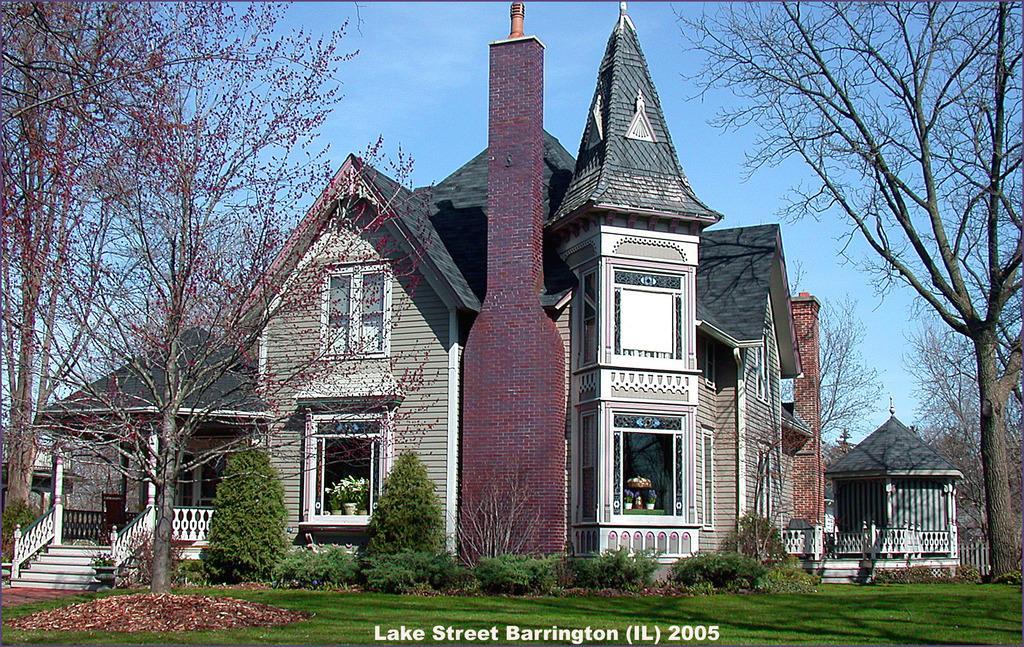How would you summarize this image in a sentence or two? In this image, we can see some buildings and there are some trees, we can see some plants and there is green grass on the ground, we can see the stairs and railing, at the top there is a blue sky. 